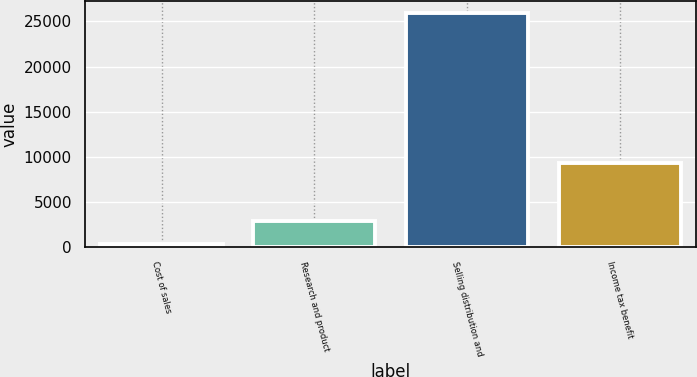<chart> <loc_0><loc_0><loc_500><loc_500><bar_chart><fcel>Cost of sales<fcel>Research and product<fcel>Selling distribution and<fcel>Income tax benefit<nl><fcel>374<fcel>2928.4<fcel>25918<fcel>9359<nl></chart> 